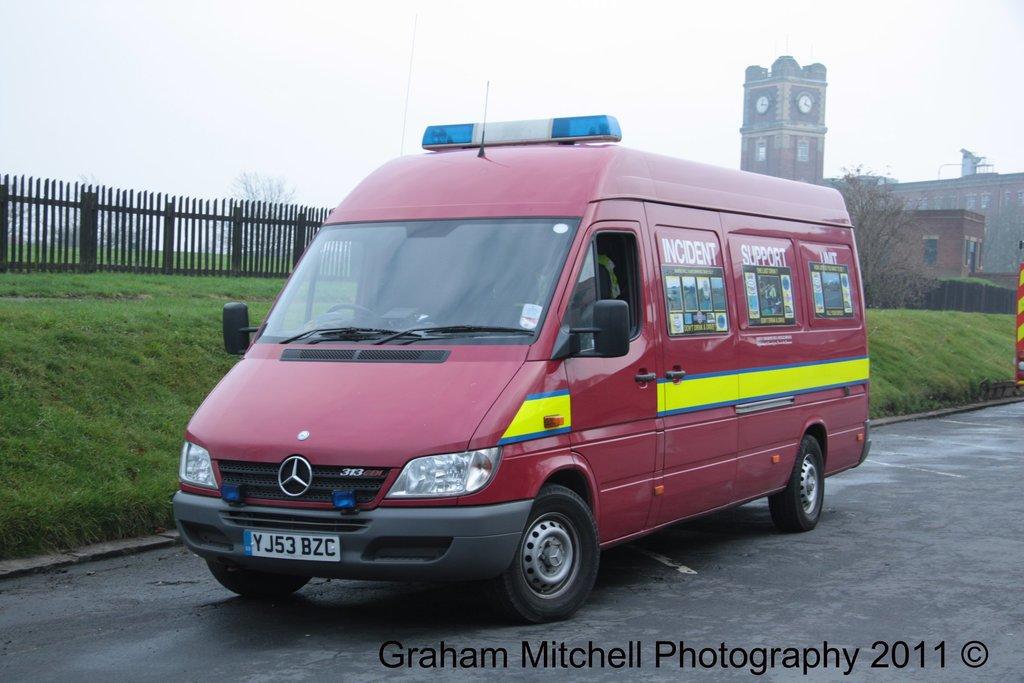What photography company took this?
Provide a succinct answer. Graham mitchell photography. What unit is the vehicle from?
Offer a very short reply. Incident support. 